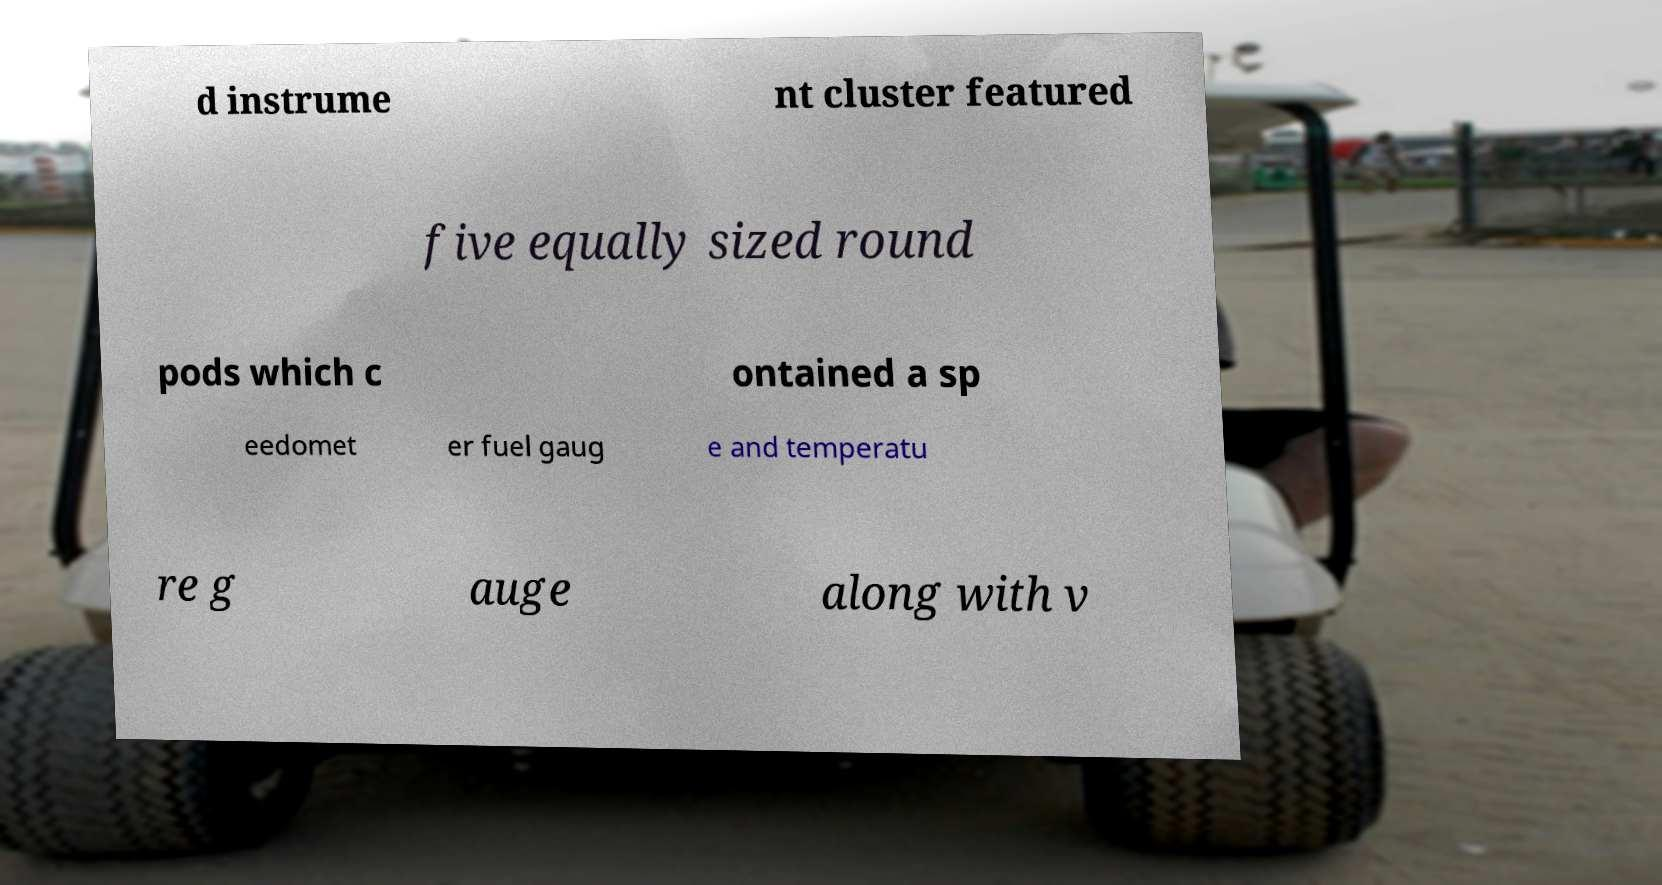For documentation purposes, I need the text within this image transcribed. Could you provide that? d instrume nt cluster featured five equally sized round pods which c ontained a sp eedomet er fuel gaug e and temperatu re g auge along with v 